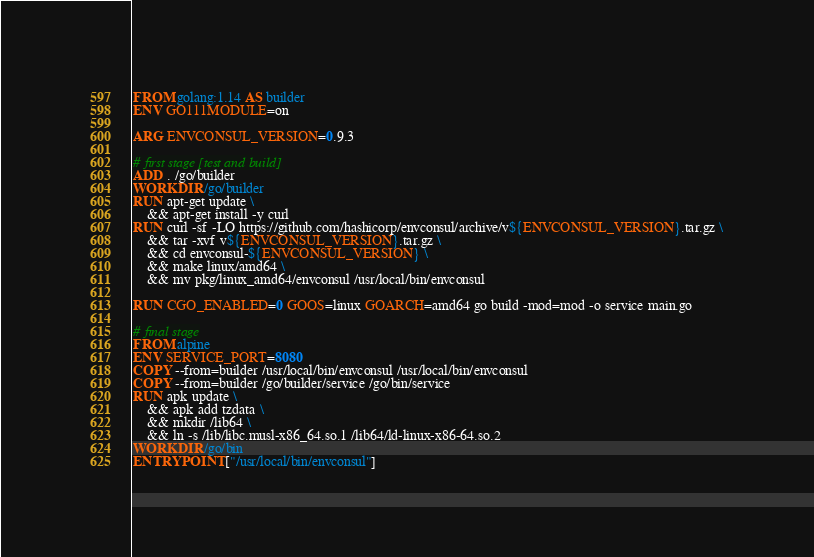Convert code to text. <code><loc_0><loc_0><loc_500><loc_500><_Dockerfile_>FROM golang:1.14 AS builder
ENV GO111MODULE=on

ARG ENVCONSUL_VERSION=0.9.3

# first stage [test and build]
ADD . /go/builder
WORKDIR /go/builder
RUN apt-get update \
    && apt-get install -y curl
RUN curl -sf -LO https://github.com/hashicorp/envconsul/archive/v${ENVCONSUL_VERSION}.tar.gz \
    && tar -xvf v${ENVCONSUL_VERSION}.tar.gz \
    && cd envconsul-${ENVCONSUL_VERSION} \
    && make linux/amd64 \
    && mv pkg/linux_amd64/envconsul /usr/local/bin/envconsul

RUN CGO_ENABLED=0 GOOS=linux GOARCH=amd64 go build -mod=mod -o service main.go

# final stage
FROM alpine
ENV SERVICE_PORT=8080
COPY --from=builder /usr/local/bin/envconsul /usr/local/bin/envconsul
COPY --from=builder /go/builder/service /go/bin/service
RUN apk update \
    && apk add tzdata \
    && mkdir /lib64 \
    && ln -s /lib/libc.musl-x86_64.so.1 /lib64/ld-linux-x86-64.so.2
WORKDIR /go/bin
ENTRYPOINT ["/usr/local/bin/envconsul"]</code> 